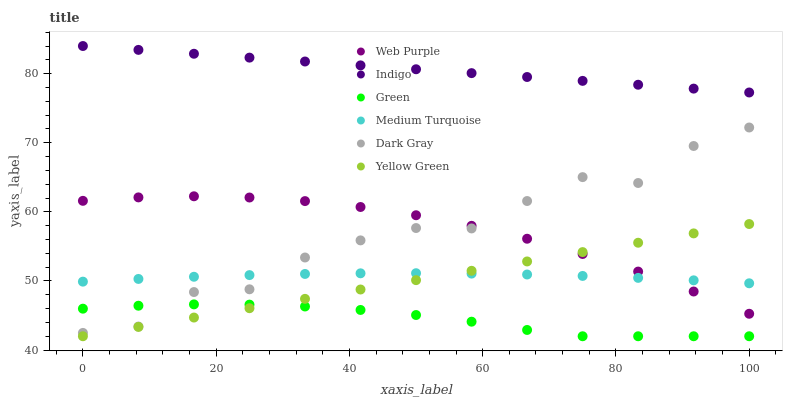Does Green have the minimum area under the curve?
Answer yes or no. Yes. Does Indigo have the maximum area under the curve?
Answer yes or no. Yes. Does Yellow Green have the minimum area under the curve?
Answer yes or no. No. Does Yellow Green have the maximum area under the curve?
Answer yes or no. No. Is Yellow Green the smoothest?
Answer yes or no. Yes. Is Dark Gray the roughest?
Answer yes or no. Yes. Is Dark Gray the smoothest?
Answer yes or no. No. Is Yellow Green the roughest?
Answer yes or no. No. Does Yellow Green have the lowest value?
Answer yes or no. Yes. Does Dark Gray have the lowest value?
Answer yes or no. No. Does Indigo have the highest value?
Answer yes or no. Yes. Does Yellow Green have the highest value?
Answer yes or no. No. Is Green less than Medium Turquoise?
Answer yes or no. Yes. Is Web Purple greater than Green?
Answer yes or no. Yes. Does Green intersect Yellow Green?
Answer yes or no. Yes. Is Green less than Yellow Green?
Answer yes or no. No. Is Green greater than Yellow Green?
Answer yes or no. No. Does Green intersect Medium Turquoise?
Answer yes or no. No. 